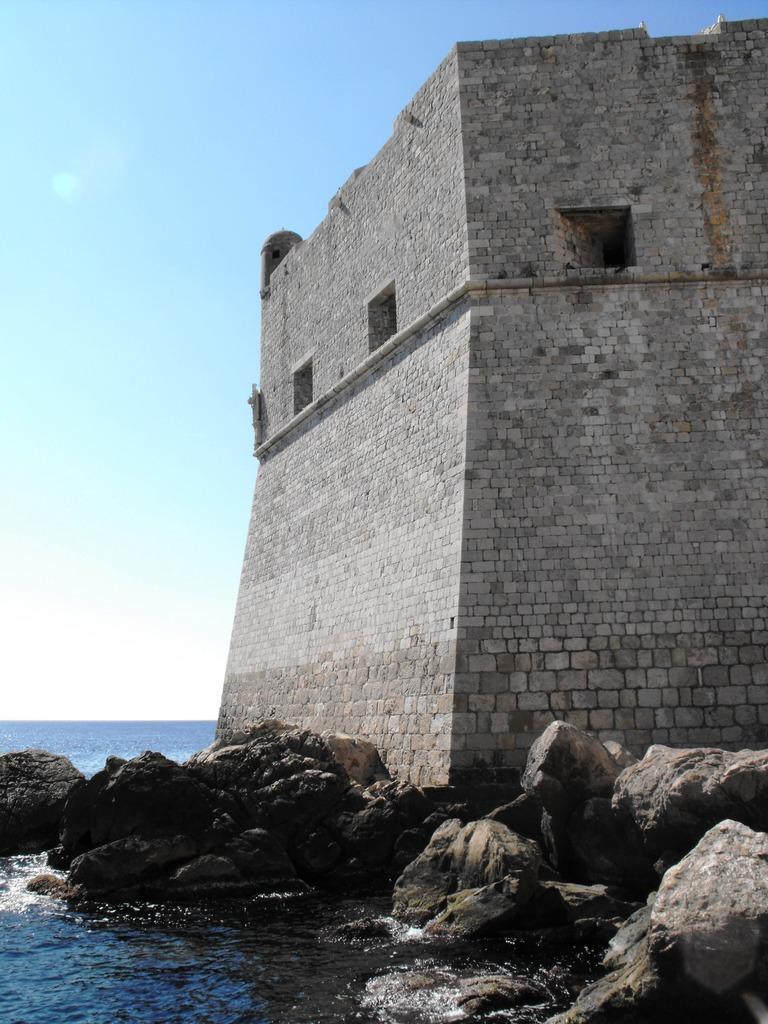Could you give a brief overview of what you see in this image? This picture is clicked outside the city. In the foreground we can see a water body and the rocks. On the right there is a building and we can see the windows and the wall of a building. In the background there is a sky. 